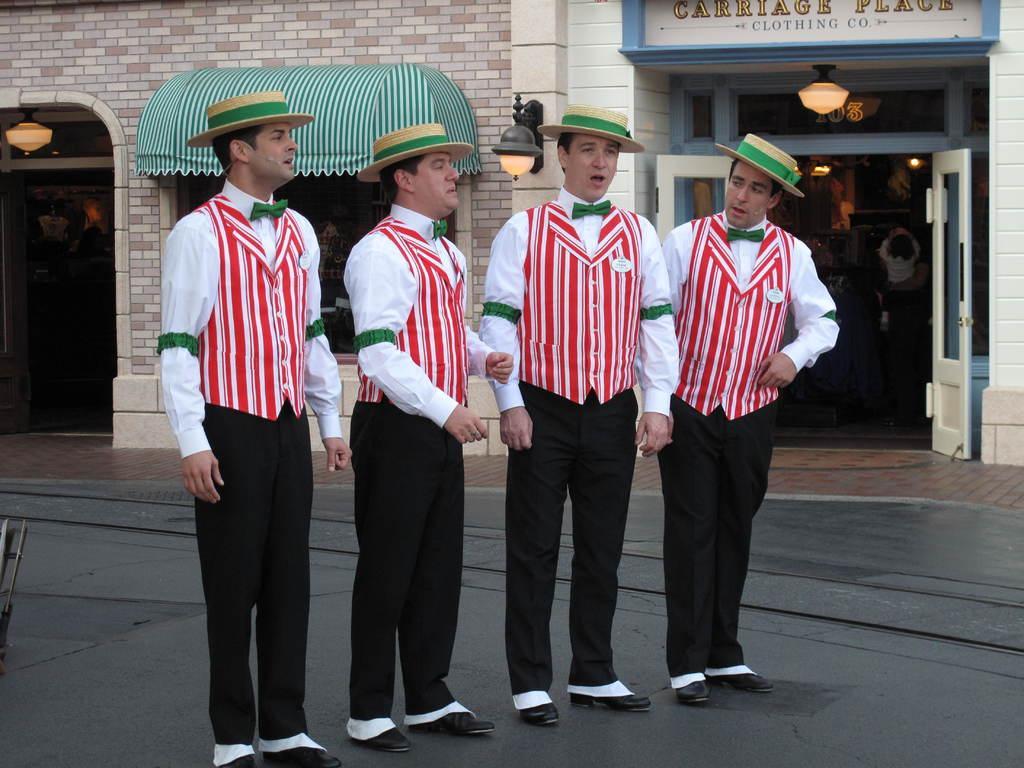Could you give a brief overview of what you see in this image? In this picture there are group of people with white shirts and black pants are standing on the road. At the back there is a building and there is a board on the building and there is a text on the board and there are lights on the wall. At the back there is a door and there are group of people inside the room and there are lights. At the bottom there is a road. 